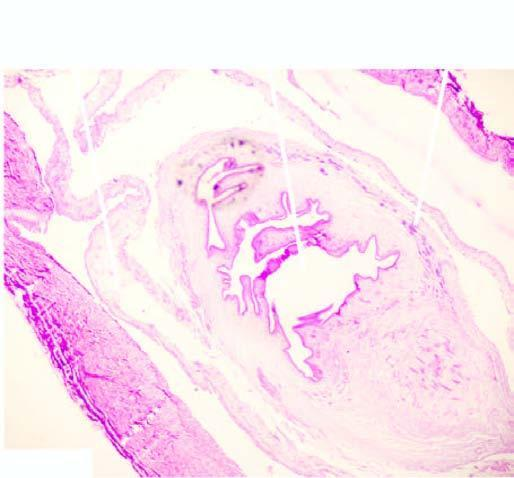what is the worm seen in while the cyst wall shows palisade layer of histiocytes?
Answer the question using a single word or phrase. In the cyst 